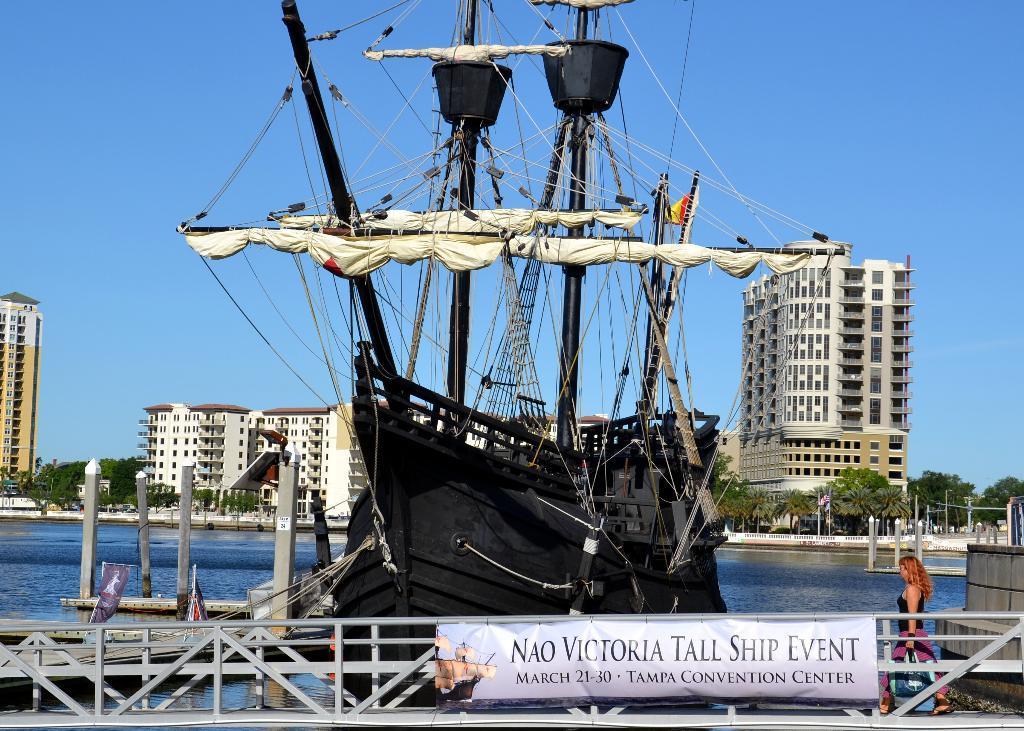How would you summarize this image in a sentence or two? In the picture we can see a walking bridge with a railing to it and woman standing over there and behind the bridge we can see a boat which is black in color with some poles and wires to it and behind the boat we can see water and far away from it we can see some buildings, poles and trees near it and we can see the sky behind it. 